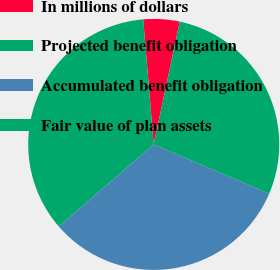Convert chart. <chart><loc_0><loc_0><loc_500><loc_500><pie_chart><fcel>In millions of dollars<fcel>Projected benefit obligation<fcel>Accumulated benefit obligation<fcel>Fair value of plan assets<nl><fcel>4.66%<fcel>35.0%<fcel>32.24%<fcel>28.09%<nl></chart> 